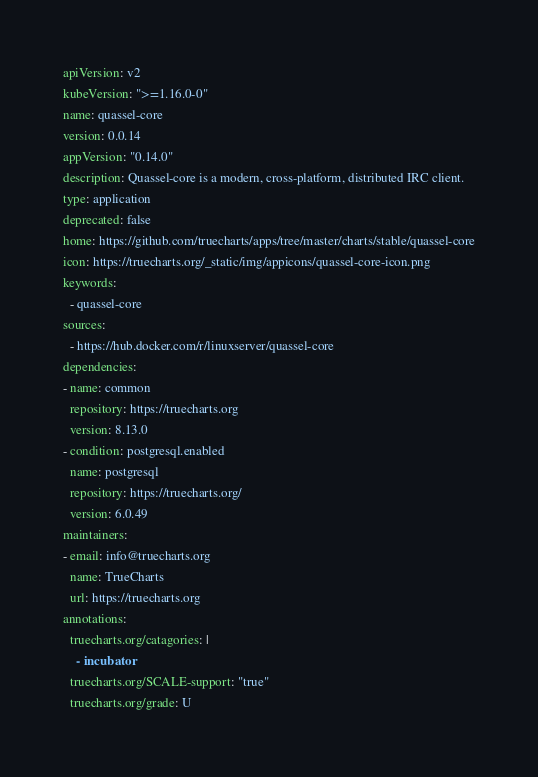Convert code to text. <code><loc_0><loc_0><loc_500><loc_500><_YAML_>apiVersion: v2
kubeVersion: ">=1.16.0-0"
name: quassel-core
version: 0.0.14
appVersion: "0.14.0"
description: Quassel-core is a modern, cross-platform, distributed IRC client.
type: application
deprecated: false
home: https://github.com/truecharts/apps/tree/master/charts/stable/quassel-core
icon: https://truecharts.org/_static/img/appicons/quassel-core-icon.png
keywords:
  - quassel-core
sources:
  - https://hub.docker.com/r/linuxserver/quassel-core
dependencies:
- name: common
  repository: https://truecharts.org
  version: 8.13.0
- condition: postgresql.enabled
  name: postgresql
  repository: https://truecharts.org/
  version: 6.0.49
maintainers:
- email: info@truecharts.org
  name: TrueCharts
  url: https://truecharts.org
annotations:
  truecharts.org/catagories: |
    - incubator
  truecharts.org/SCALE-support: "true"
  truecharts.org/grade: U
</code> 